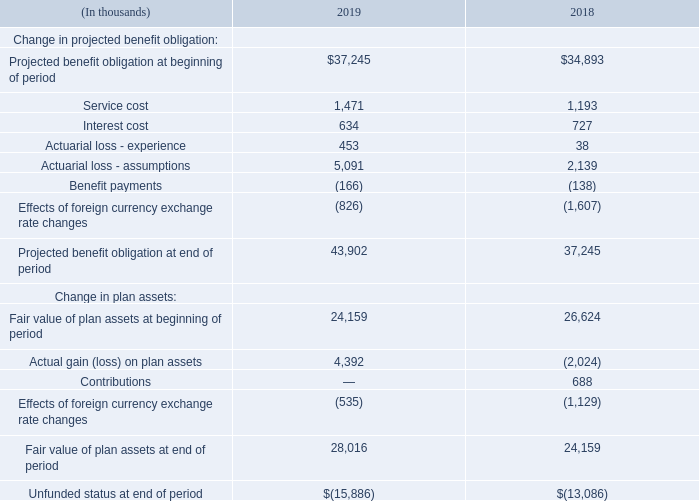Note 14 – Employee Benefit Plans
Pension Benefit Plan
We maintain a defined benefit pension plan covering employees in certain foreign countries.
The pension benefit plan obligations and funded status as of December 31, 2019 and 2018, were as follows:
The accumulated benefit obligation was $43.9 million and $37.2 million as of December 31, 2019 and 2018, respectively. The increase in the accumulated benefit obligation and the actuarial loss was primarily attributable to a decrease in the discount rate during 2019.
What was the accumulated benefit obligation in 2019? $43.9 million. What does the table show? Pension benefit plan obligations and funded status as of december 31, 2019 and 2018. What was the service cost in 2019?
Answer scale should be: thousand. 1,471. What was the change in service cost between 2018 and 2019?
Answer scale should be: thousand. 1,471-1,193
Answer: 278. What was the change in interest cost between 2018 and 2019?
Answer scale should be: thousand. 634-727
Answer: -93. What was the percentage change in the fair value of plan assets at end of period between 2018 and 2019?
Answer scale should be: percent. (28,016-24,159)/24,159
Answer: 15.97. 